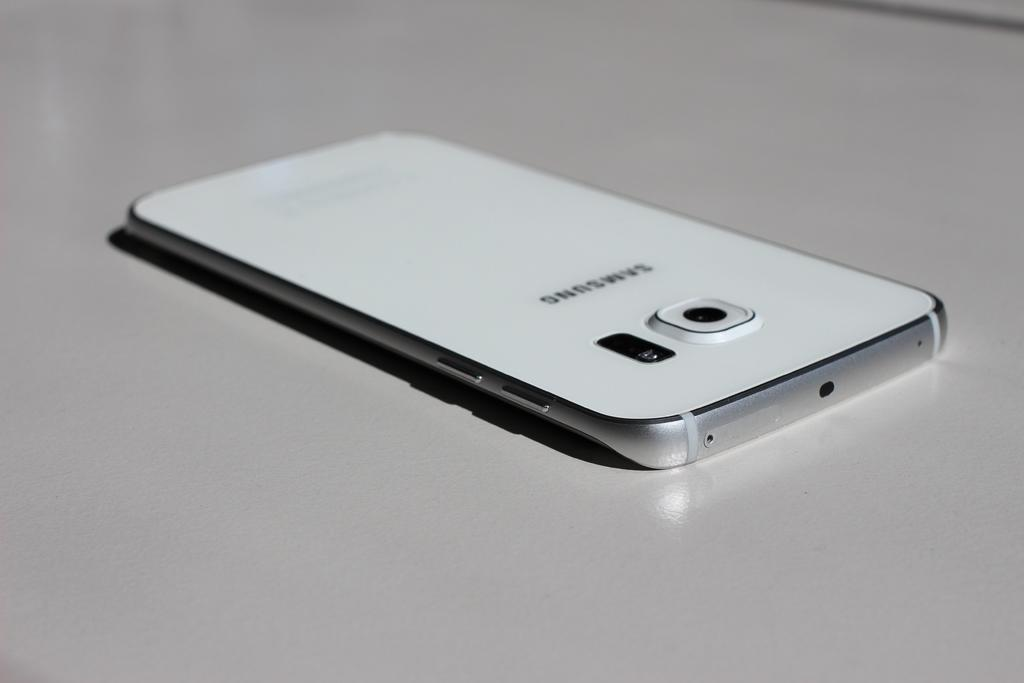<image>
Present a compact description of the photo's key features. A white cell phone is face down on a white surface and says Samsung on the back. 